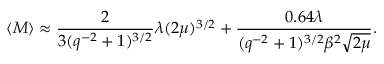<formula> <loc_0><loc_0><loc_500><loc_500>\langle M \rangle \approx \frac { 2 } { 3 ( q ^ { - 2 } + 1 ) ^ { 3 / 2 } } \lambda ( 2 \mu ) ^ { 3 / 2 } + \frac { 0 . 6 4 \lambda } { ( q ^ { - 2 } + 1 ) ^ { 3 / 2 } \beta ^ { 2 } \sqrt { 2 \mu } } .</formula> 